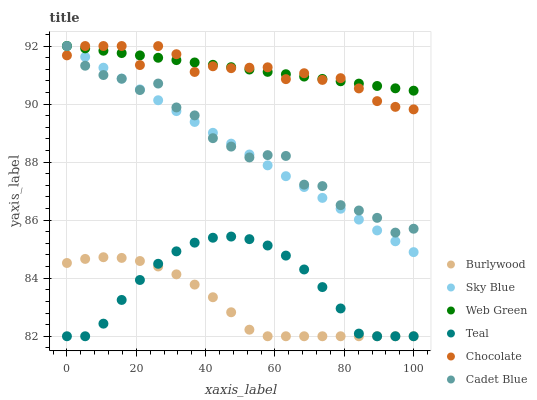Does Burlywood have the minimum area under the curve?
Answer yes or no. Yes. Does Web Green have the maximum area under the curve?
Answer yes or no. Yes. Does Web Green have the minimum area under the curve?
Answer yes or no. No. Does Burlywood have the maximum area under the curve?
Answer yes or no. No. Is Web Green the smoothest?
Answer yes or no. Yes. Is Cadet Blue the roughest?
Answer yes or no. Yes. Is Burlywood the smoothest?
Answer yes or no. No. Is Burlywood the roughest?
Answer yes or no. No. Does Burlywood have the lowest value?
Answer yes or no. Yes. Does Web Green have the lowest value?
Answer yes or no. No. Does Sky Blue have the highest value?
Answer yes or no. Yes. Does Burlywood have the highest value?
Answer yes or no. No. Is Teal less than Chocolate?
Answer yes or no. Yes. Is Sky Blue greater than Burlywood?
Answer yes or no. Yes. Does Chocolate intersect Web Green?
Answer yes or no. Yes. Is Chocolate less than Web Green?
Answer yes or no. No. Is Chocolate greater than Web Green?
Answer yes or no. No. Does Teal intersect Chocolate?
Answer yes or no. No. 